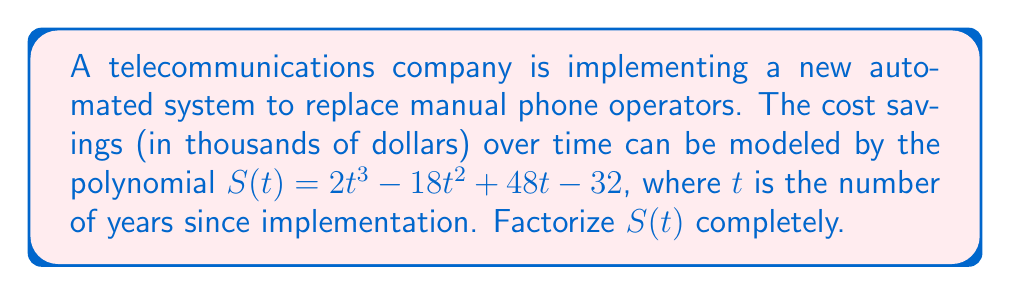Help me with this question. Let's approach this step-by-step:

1) First, we need to check if there are any common factors. In this case, there are no common factors for all terms.

2) Next, we can try to guess a factor. Since the constant term is -32, possible factors could be ±1, ±2, ±4, ±8, ±16, ±32. Let's try these:

   $S(1) = 2(1)^3 - 18(1)^2 + 48(1) - 32 = 2 - 18 + 48 - 32 = 0$

   This means $(t-1)$ is a factor.

3) We can use polynomial long division to divide $S(t)$ by $(t-1)$:

   $$\frac{2t^3 - 18t^2 + 48t - 32}{t - 1} = 2t^2 - 16t + 32$$

4) So now we have: $S(t) = (t-1)(2t^2 - 16t + 32)$

5) We can factor the quadratic term $2t^2 - 16t + 32$ further:
   
   $2t^2 - 16t + 32 = 2(t^2 - 8t + 16) = 2(t - 4)^2$

6) Therefore, the complete factorization is:

   $S(t) = (t-1)(2(t-4)^2) = 2(t-1)(t-4)^2$
Answer: $2(t-1)(t-4)^2$ 